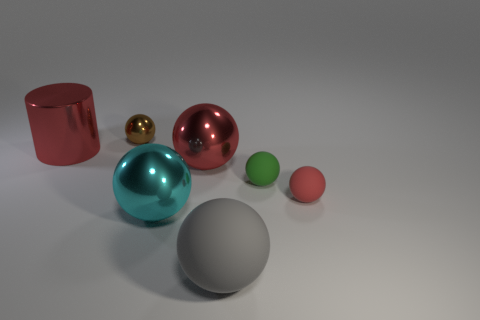How do the different materials of the objects affect the lighting in the scene? The materials of the objects vary from matte to highly reflective, causing them to interact with the light differently. The metallic and shiny surfaces of the red cylinder and the golden sphere reflect the light strongly, creating bright highlights and defined reflections, while the matte surface of the gray sphere diffuses the light, resulting in a softer appearance without distinct reflections. 